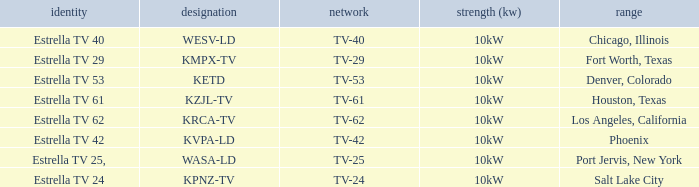Can you give me this table as a dict? {'header': ['identity', 'designation', 'network', 'strength (kw)', 'range'], 'rows': [['Estrella TV 40', 'WESV-LD', 'TV-40', '10kW', 'Chicago, Illinois'], ['Estrella TV 29', 'KMPX-TV', 'TV-29', '10kW', 'Fort Worth, Texas'], ['Estrella TV 53', 'KETD', 'TV-53', '10kW', 'Denver, Colorado'], ['Estrella TV 61', 'KZJL-TV', 'TV-61', '10kW', 'Houston, Texas'], ['Estrella TV 62', 'KRCA-TV', 'TV-62', '10kW', 'Los Angeles, California'], ['Estrella TV 42', 'KVPA-LD', 'TV-42', '10kW', 'Phoenix'], ['Estrella TV 25,', 'WASA-LD', 'TV-25', '10kW', 'Port Jervis, New York'], ['Estrella TV 24', 'KPNZ-TV', 'TV-24', '10kW', 'Salt Lake City']]} Which city did kpnz-tv provide coverage for? Salt Lake City. 